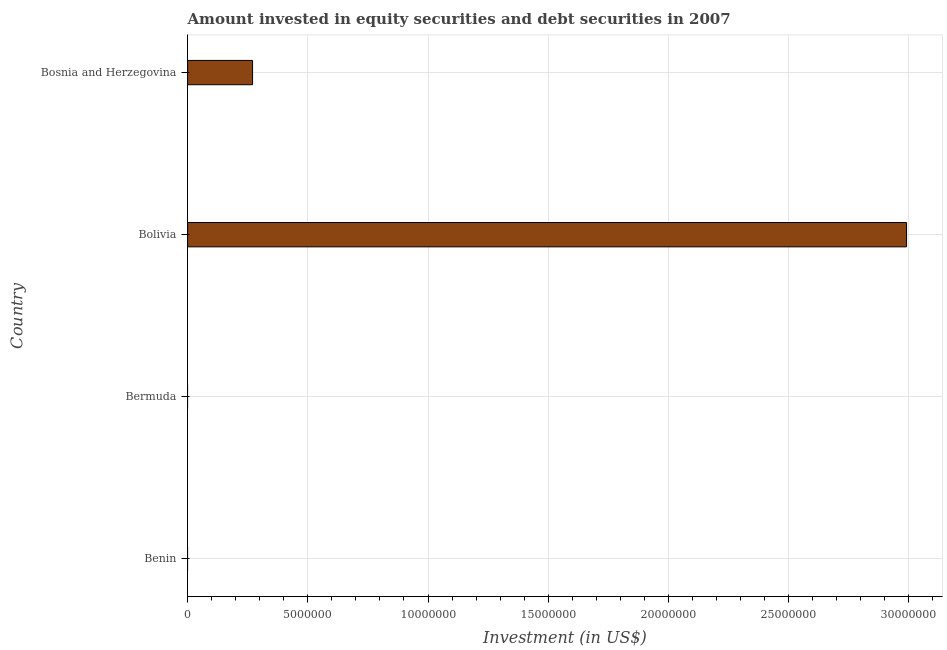Does the graph contain any zero values?
Offer a terse response. Yes. What is the title of the graph?
Ensure brevity in your answer.  Amount invested in equity securities and debt securities in 2007. What is the label or title of the X-axis?
Your answer should be compact. Investment (in US$). What is the portfolio investment in Bermuda?
Provide a succinct answer. 0. Across all countries, what is the maximum portfolio investment?
Provide a succinct answer. 2.99e+07. In which country was the portfolio investment maximum?
Offer a very short reply. Bolivia. What is the sum of the portfolio investment?
Keep it short and to the point. 3.26e+07. What is the difference between the portfolio investment in Bolivia and Bosnia and Herzegovina?
Offer a terse response. 2.72e+07. What is the average portfolio investment per country?
Ensure brevity in your answer.  8.15e+06. What is the median portfolio investment?
Give a very brief answer. 1.35e+06. In how many countries, is the portfolio investment greater than 6000000 US$?
Provide a succinct answer. 1. What is the ratio of the portfolio investment in Bolivia to that in Bosnia and Herzegovina?
Make the answer very short. 11.07. What is the difference between the highest and the lowest portfolio investment?
Provide a succinct answer. 2.99e+07. In how many countries, is the portfolio investment greater than the average portfolio investment taken over all countries?
Your answer should be compact. 1. How many bars are there?
Your answer should be very brief. 2. Are all the bars in the graph horizontal?
Your answer should be very brief. Yes. What is the Investment (in US$) of Bolivia?
Give a very brief answer. 2.99e+07. What is the Investment (in US$) in Bosnia and Herzegovina?
Offer a terse response. 2.70e+06. What is the difference between the Investment (in US$) in Bolivia and Bosnia and Herzegovina?
Keep it short and to the point. 2.72e+07. What is the ratio of the Investment (in US$) in Bolivia to that in Bosnia and Herzegovina?
Make the answer very short. 11.07. 